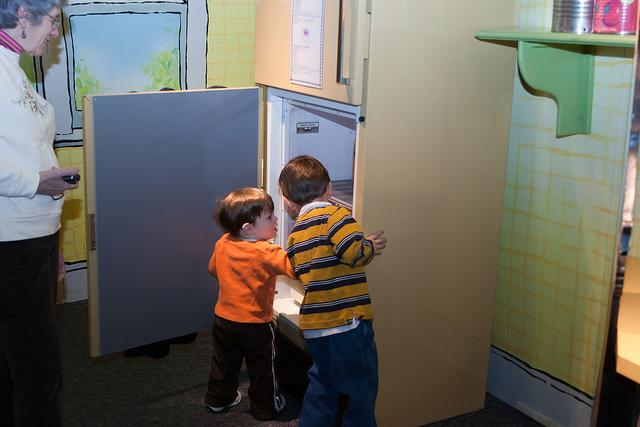The wall decoration and props here are modeled after which location? Please explain your reasoning. kitchen. It's obvious by the fridge that the kids are look inside of. 